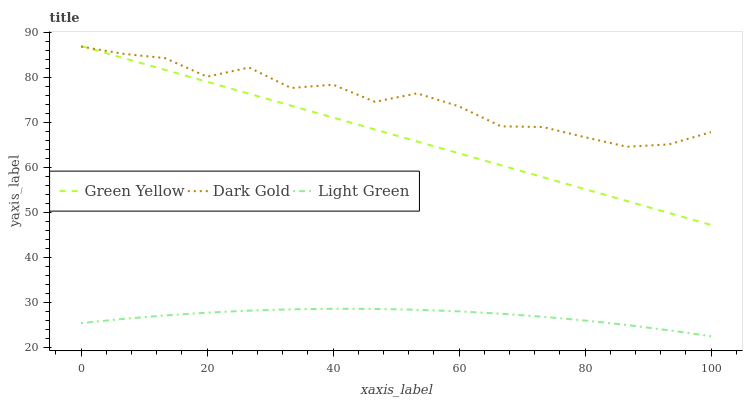Does Light Green have the minimum area under the curve?
Answer yes or no. Yes. Does Dark Gold have the maximum area under the curve?
Answer yes or no. Yes. Does Dark Gold have the minimum area under the curve?
Answer yes or no. No. Does Light Green have the maximum area under the curve?
Answer yes or no. No. Is Green Yellow the smoothest?
Answer yes or no. Yes. Is Dark Gold the roughest?
Answer yes or no. Yes. Is Light Green the smoothest?
Answer yes or no. No. Is Light Green the roughest?
Answer yes or no. No. Does Dark Gold have the lowest value?
Answer yes or no. No. Does Green Yellow have the highest value?
Answer yes or no. Yes. Does Dark Gold have the highest value?
Answer yes or no. No. Is Light Green less than Green Yellow?
Answer yes or no. Yes. Is Green Yellow greater than Light Green?
Answer yes or no. Yes. Does Dark Gold intersect Green Yellow?
Answer yes or no. Yes. Is Dark Gold less than Green Yellow?
Answer yes or no. No. Is Dark Gold greater than Green Yellow?
Answer yes or no. No. Does Light Green intersect Green Yellow?
Answer yes or no. No. 